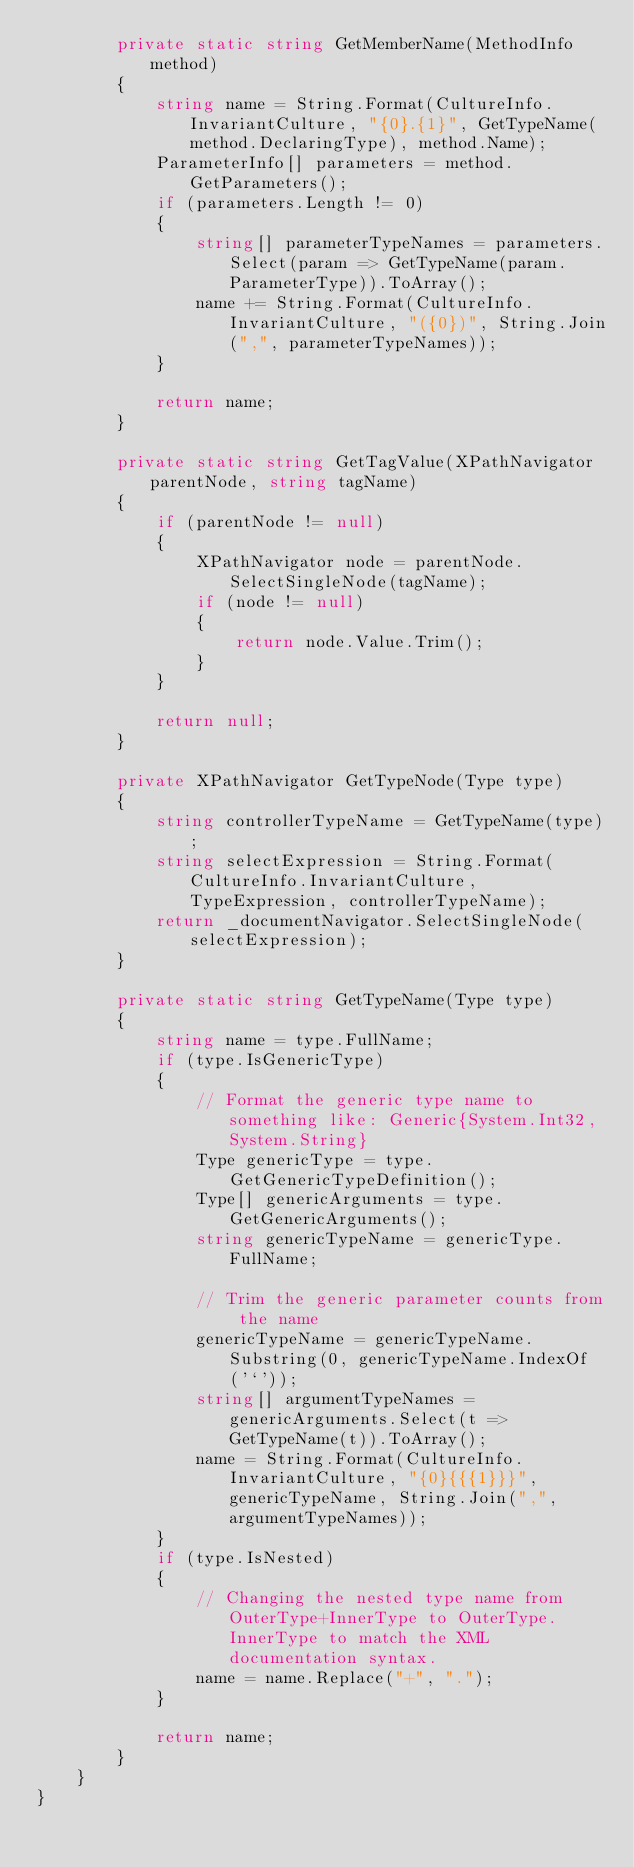<code> <loc_0><loc_0><loc_500><loc_500><_C#_>        private static string GetMemberName(MethodInfo method)
        {
            string name = String.Format(CultureInfo.InvariantCulture, "{0}.{1}", GetTypeName(method.DeclaringType), method.Name);
            ParameterInfo[] parameters = method.GetParameters();
            if (parameters.Length != 0)
            {
                string[] parameterTypeNames = parameters.Select(param => GetTypeName(param.ParameterType)).ToArray();
                name += String.Format(CultureInfo.InvariantCulture, "({0})", String.Join(",", parameterTypeNames));
            }

            return name;
        }

        private static string GetTagValue(XPathNavigator parentNode, string tagName)
        {
            if (parentNode != null)
            {
                XPathNavigator node = parentNode.SelectSingleNode(tagName);
                if (node != null)
                {
                    return node.Value.Trim();
                }
            }

            return null;
        }

        private XPathNavigator GetTypeNode(Type type)
        {
            string controllerTypeName = GetTypeName(type);
            string selectExpression = String.Format(CultureInfo.InvariantCulture, TypeExpression, controllerTypeName);
            return _documentNavigator.SelectSingleNode(selectExpression);
        }

        private static string GetTypeName(Type type)
        {
            string name = type.FullName;
            if (type.IsGenericType)
            {
                // Format the generic type name to something like: Generic{System.Int32,System.String}
                Type genericType = type.GetGenericTypeDefinition();
                Type[] genericArguments = type.GetGenericArguments();
                string genericTypeName = genericType.FullName;

                // Trim the generic parameter counts from the name
                genericTypeName = genericTypeName.Substring(0, genericTypeName.IndexOf('`'));
                string[] argumentTypeNames = genericArguments.Select(t => GetTypeName(t)).ToArray();
                name = String.Format(CultureInfo.InvariantCulture, "{0}{{{1}}}", genericTypeName, String.Join(",", argumentTypeNames));
            }
            if (type.IsNested)
            {
                // Changing the nested type name from OuterType+InnerType to OuterType.InnerType to match the XML documentation syntax.
                name = name.Replace("+", ".");
            }

            return name;
        }
    }
}
</code> 